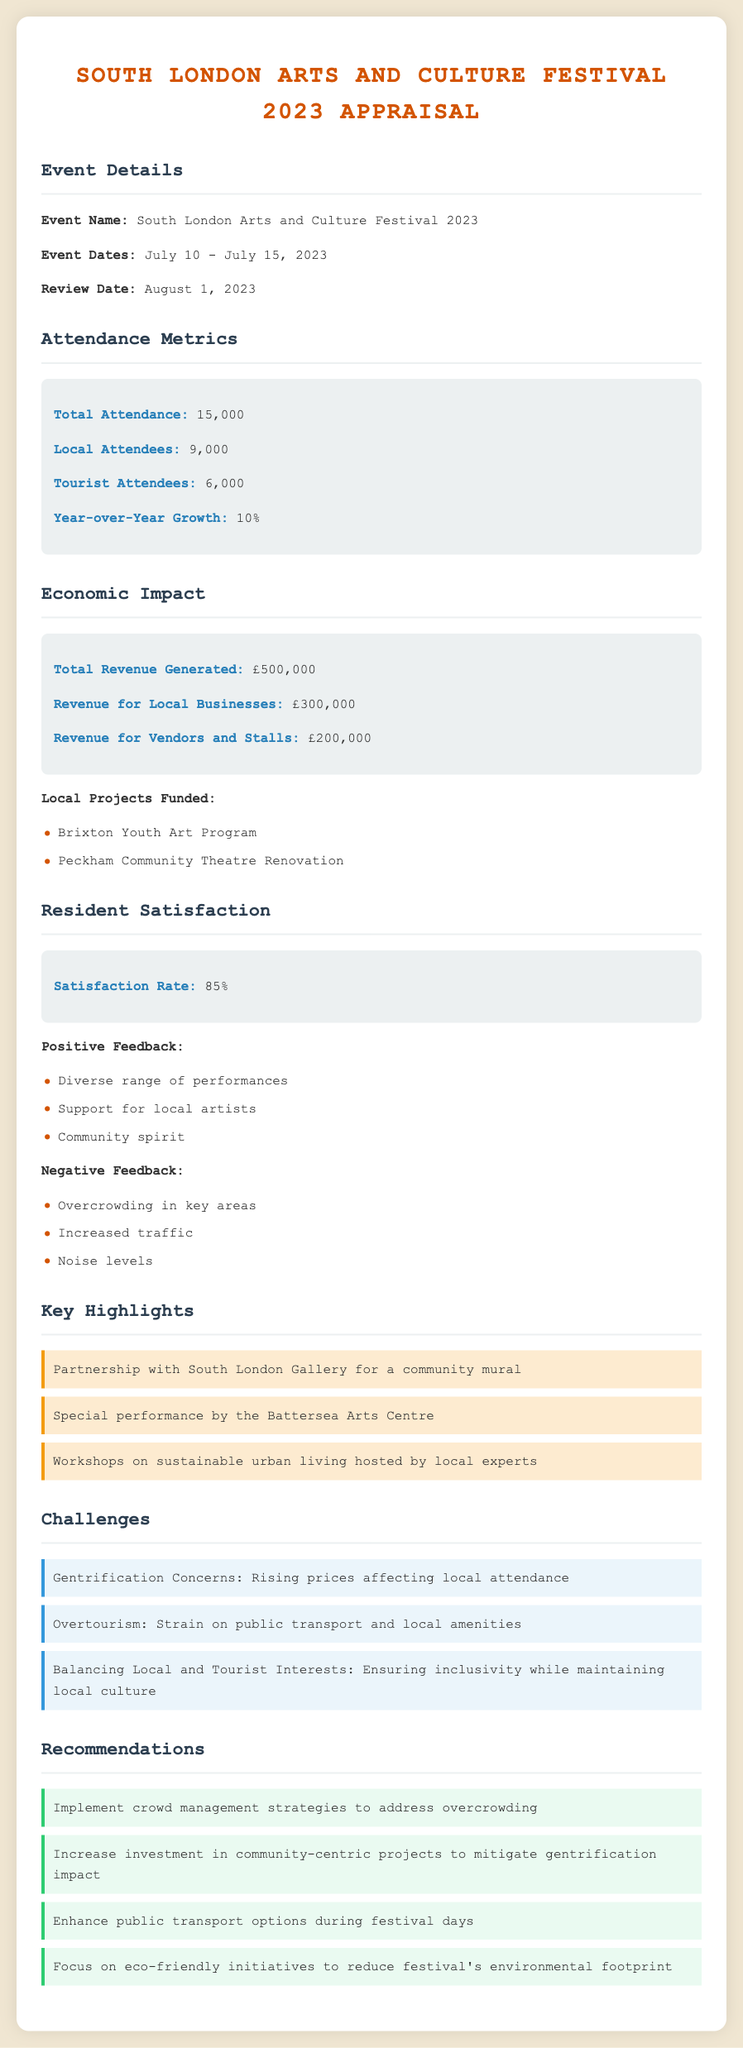What were the event dates? The event dates are specified under the Event Details section, which lists the start and end dates of the festival.
Answer: July 10 - July 15, 2023 What was the total attendance? The total attendance can be found in the Attendance Metrics section, indicating the overall number of attendees at the festival.
Answer: 15,000 What was the revenue generated for local businesses? This value is explicitly stated in the Economic Impact section as the revenue attributed to local businesses during the festival.
Answer: £300,000 What was the resident satisfaction rate? The resident satisfaction rate is highlighted in the Resident Satisfaction section, representing the percentage of satisfied attendees.
Answer: 85% What is one of the negative feedback points mentioned? The document lists several feedback points, especially under the Resident Satisfaction section, summarizing local concerns.
Answer: Overcrowding in key areas What are the challenges related to urban gentrification stated? The challenges section outlines several concerns regarding gentrification and its impact on the local community, emphasizing specific local issues.
Answer: Rising prices affecting local attendance What is a recommendation given for addressing overcrowding? The recommendations include suggested actions to improve the festival experience, which can be derived from the corresponding section.
Answer: Implement crowd management strategies Name a local project funded by the festival revenue. The document lists local projects supported by the festival's financial success, mentioned in the Economic Impact section.
Answer: Brixton Youth Art Program 